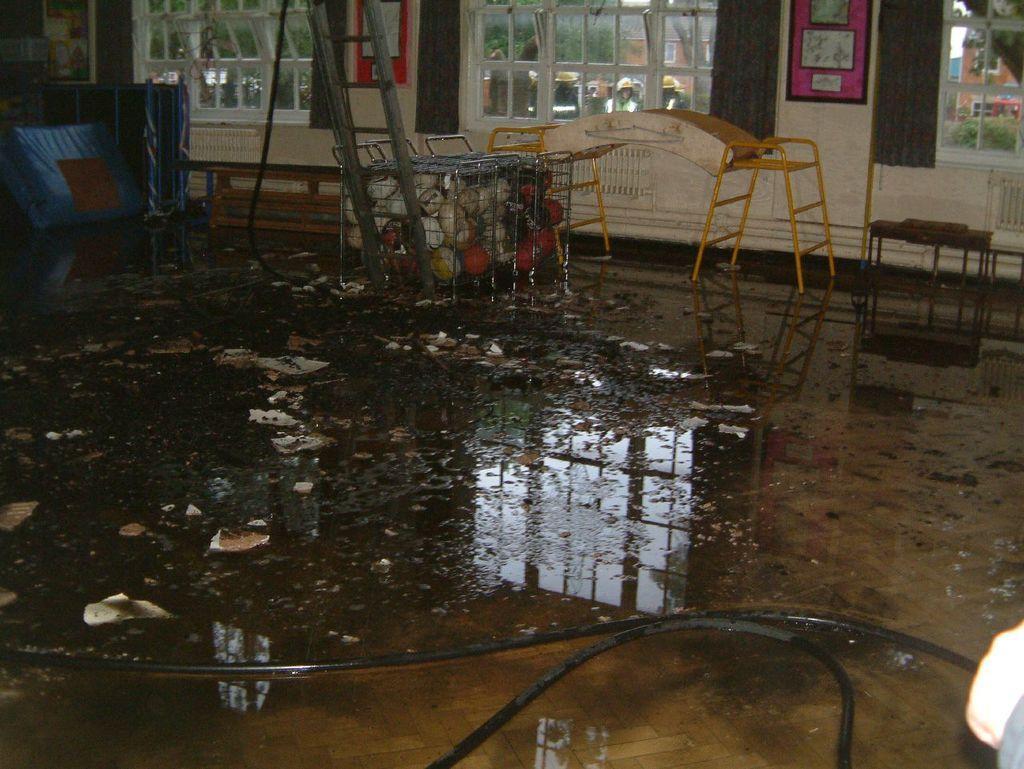In one or two sentences, can you explain what this image depicts? In this image I can see water, pipes and some other objects on the floor. Here I can see windows and some objects attached to the wall. 